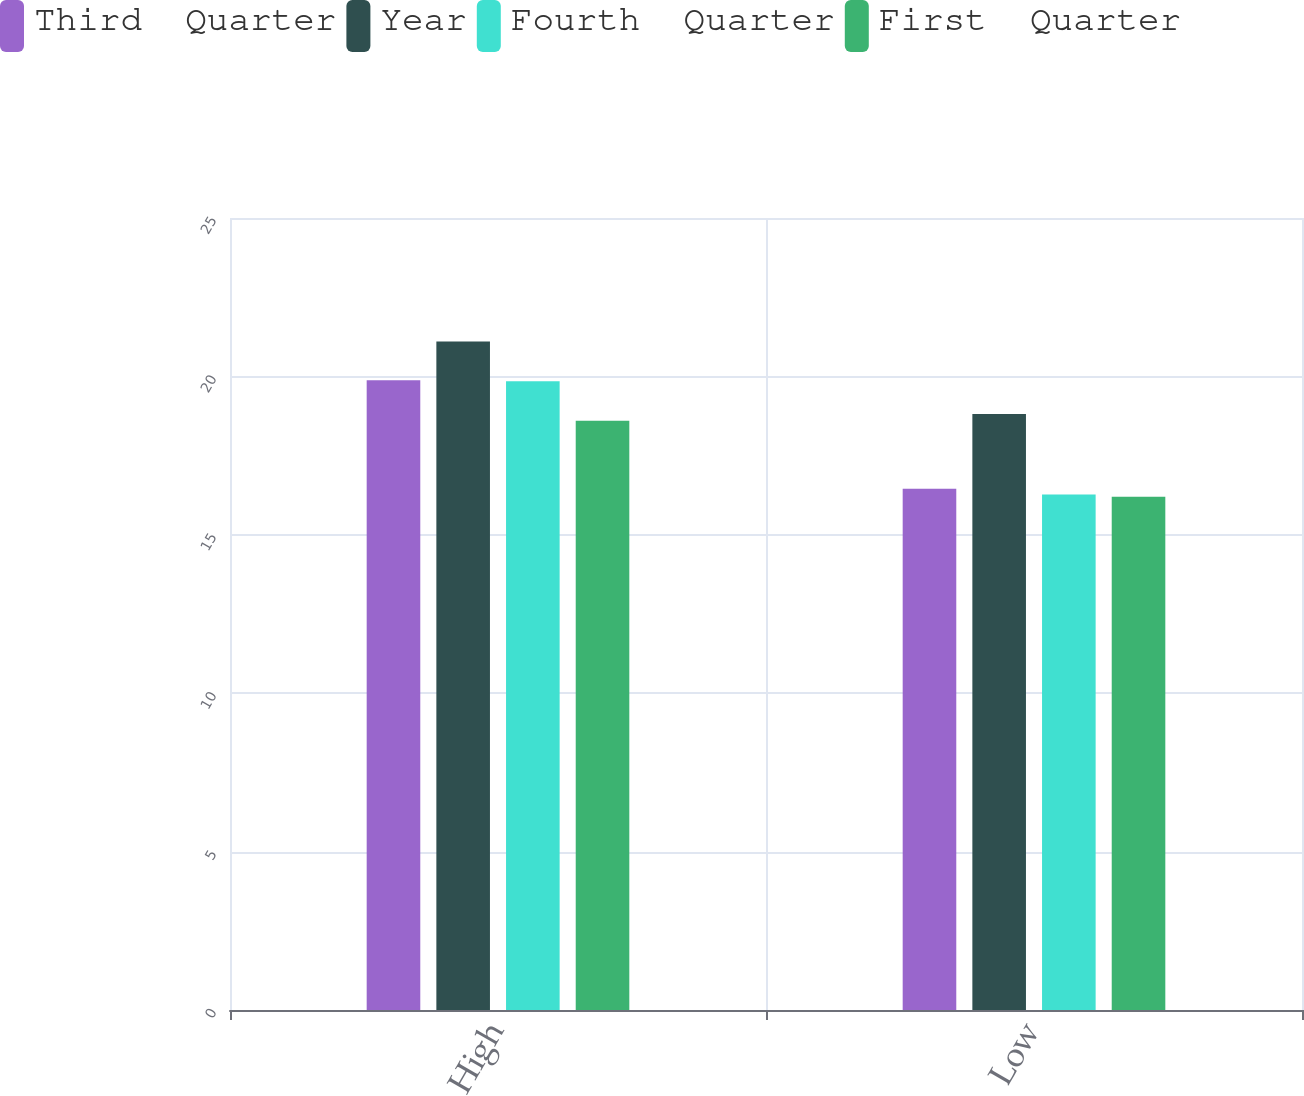Convert chart to OTSL. <chart><loc_0><loc_0><loc_500><loc_500><stacked_bar_chart><ecel><fcel>High<fcel>Low<nl><fcel>Third  Quarter<fcel>19.88<fcel>16.45<nl><fcel>Year<fcel>21.1<fcel>18.81<nl><fcel>Fourth  Quarter<fcel>19.85<fcel>16.27<nl><fcel>First  Quarter<fcel>18.6<fcel>16.2<nl></chart> 